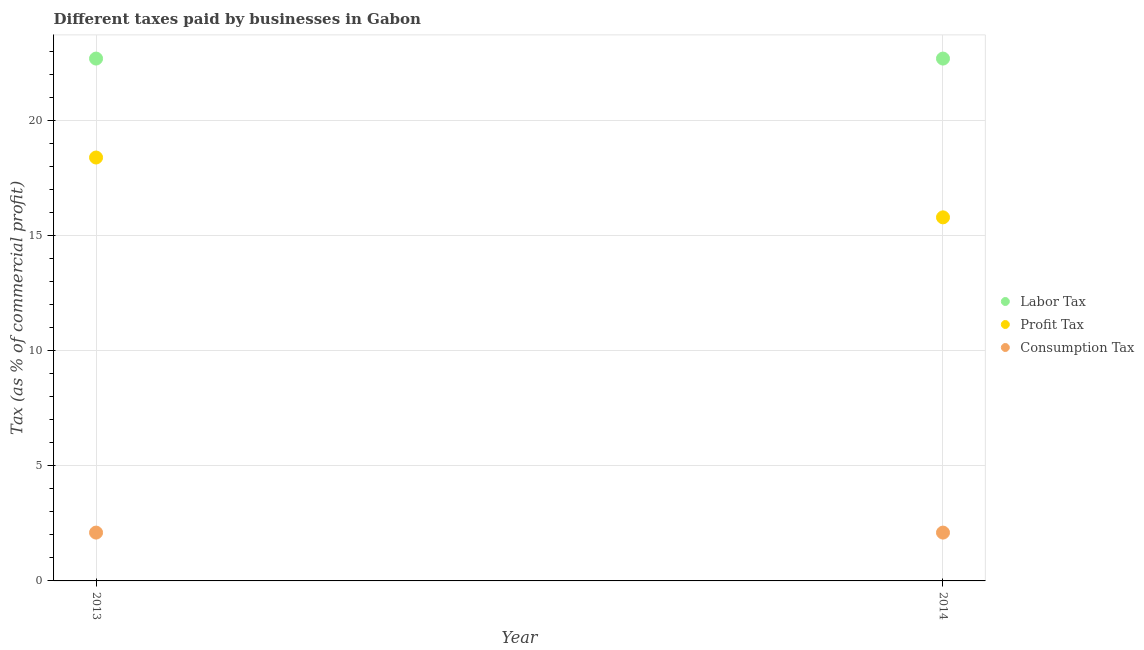How many different coloured dotlines are there?
Offer a very short reply. 3. Is the number of dotlines equal to the number of legend labels?
Provide a short and direct response. Yes. Across all years, what is the maximum percentage of consumption tax?
Provide a short and direct response. 2.1. Across all years, what is the minimum percentage of profit tax?
Provide a succinct answer. 15.8. In which year was the percentage of profit tax maximum?
Give a very brief answer. 2013. What is the total percentage of profit tax in the graph?
Offer a very short reply. 34.2. What is the difference between the percentage of labor tax in 2013 and that in 2014?
Give a very brief answer. 0. What is the difference between the percentage of consumption tax in 2014 and the percentage of labor tax in 2013?
Provide a short and direct response. -20.6. What is the average percentage of labor tax per year?
Offer a very short reply. 22.7. In the year 2013, what is the difference between the percentage of profit tax and percentage of consumption tax?
Your answer should be compact. 16.3. In how many years, is the percentage of profit tax greater than 16 %?
Give a very brief answer. 1. What is the ratio of the percentage of profit tax in 2013 to that in 2014?
Your response must be concise. 1.16. Is the percentage of labor tax in 2013 less than that in 2014?
Offer a very short reply. No. Is the percentage of consumption tax strictly less than the percentage of profit tax over the years?
Make the answer very short. Yes. How many dotlines are there?
Make the answer very short. 3. Are the values on the major ticks of Y-axis written in scientific E-notation?
Offer a very short reply. No. Does the graph contain any zero values?
Your answer should be compact. No. Does the graph contain grids?
Ensure brevity in your answer.  Yes. Where does the legend appear in the graph?
Offer a terse response. Center right. How many legend labels are there?
Your answer should be very brief. 3. How are the legend labels stacked?
Ensure brevity in your answer.  Vertical. What is the title of the graph?
Offer a terse response. Different taxes paid by businesses in Gabon. What is the label or title of the Y-axis?
Provide a succinct answer. Tax (as % of commercial profit). What is the Tax (as % of commercial profit) in Labor Tax in 2013?
Your response must be concise. 22.7. What is the Tax (as % of commercial profit) in Consumption Tax in 2013?
Your response must be concise. 2.1. What is the Tax (as % of commercial profit) of Labor Tax in 2014?
Offer a very short reply. 22.7. What is the Tax (as % of commercial profit) in Profit Tax in 2014?
Your response must be concise. 15.8. What is the Tax (as % of commercial profit) in Consumption Tax in 2014?
Keep it short and to the point. 2.1. Across all years, what is the maximum Tax (as % of commercial profit) of Labor Tax?
Provide a succinct answer. 22.7. Across all years, what is the maximum Tax (as % of commercial profit) of Profit Tax?
Ensure brevity in your answer.  18.4. Across all years, what is the maximum Tax (as % of commercial profit) of Consumption Tax?
Provide a short and direct response. 2.1. Across all years, what is the minimum Tax (as % of commercial profit) of Labor Tax?
Your answer should be compact. 22.7. Across all years, what is the minimum Tax (as % of commercial profit) of Consumption Tax?
Offer a terse response. 2.1. What is the total Tax (as % of commercial profit) in Labor Tax in the graph?
Your answer should be very brief. 45.4. What is the total Tax (as % of commercial profit) in Profit Tax in the graph?
Your answer should be compact. 34.2. What is the difference between the Tax (as % of commercial profit) of Labor Tax in 2013 and that in 2014?
Provide a short and direct response. 0. What is the difference between the Tax (as % of commercial profit) in Profit Tax in 2013 and that in 2014?
Provide a short and direct response. 2.6. What is the difference between the Tax (as % of commercial profit) in Labor Tax in 2013 and the Tax (as % of commercial profit) in Consumption Tax in 2014?
Your answer should be very brief. 20.6. What is the average Tax (as % of commercial profit) in Labor Tax per year?
Provide a short and direct response. 22.7. What is the average Tax (as % of commercial profit) in Profit Tax per year?
Offer a very short reply. 17.1. In the year 2013, what is the difference between the Tax (as % of commercial profit) in Labor Tax and Tax (as % of commercial profit) in Profit Tax?
Keep it short and to the point. 4.3. In the year 2013, what is the difference between the Tax (as % of commercial profit) of Labor Tax and Tax (as % of commercial profit) of Consumption Tax?
Offer a terse response. 20.6. In the year 2014, what is the difference between the Tax (as % of commercial profit) in Labor Tax and Tax (as % of commercial profit) in Consumption Tax?
Provide a short and direct response. 20.6. In the year 2014, what is the difference between the Tax (as % of commercial profit) in Profit Tax and Tax (as % of commercial profit) in Consumption Tax?
Your answer should be compact. 13.7. What is the ratio of the Tax (as % of commercial profit) in Profit Tax in 2013 to that in 2014?
Provide a short and direct response. 1.16. What is the difference between the highest and the second highest Tax (as % of commercial profit) in Profit Tax?
Your answer should be compact. 2.6. What is the difference between the highest and the second highest Tax (as % of commercial profit) of Consumption Tax?
Your response must be concise. 0. What is the difference between the highest and the lowest Tax (as % of commercial profit) of Labor Tax?
Offer a terse response. 0. 